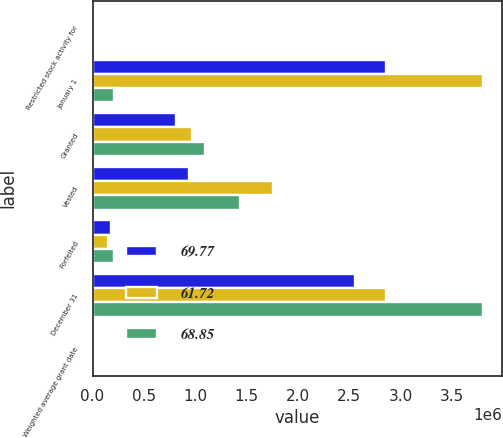<chart> <loc_0><loc_0><loc_500><loc_500><stacked_bar_chart><ecel><fcel>Restricted stock activity for<fcel>January 1<fcel>Granted<fcel>Vested<fcel>Forfeited<fcel>December 31<fcel>Weighted average grant date<nl><fcel>69.77<fcel>2018<fcel>2.85937e+06<fcel>815810<fcel>944048<fcel>177233<fcel>2.5539e+06<fcel>69.77<nl><fcel>61.72<fcel>2017<fcel>3.8021e+06<fcel>966919<fcel>1.75727e+06<fcel>152382<fcel>2.85937e+06<fcel>68.85<nl><fcel>68.85<fcel>2016<fcel>209010<fcel>1.1004e+06<fcel>1.43839e+06<fcel>209010<fcel>3.8021e+06<fcel>61.72<nl></chart> 